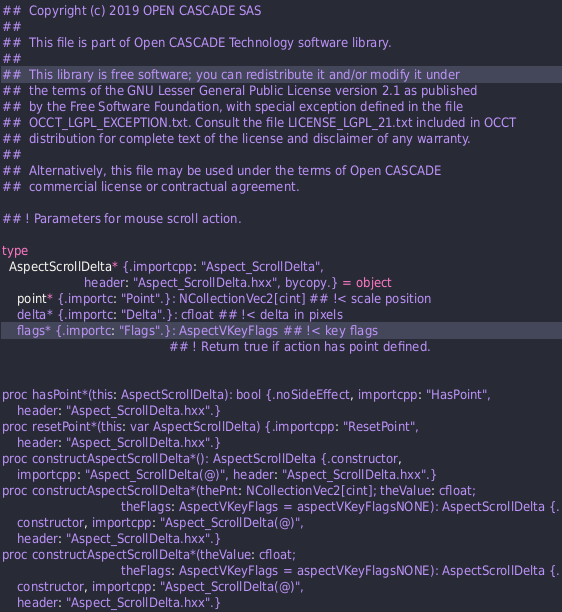<code> <loc_0><loc_0><loc_500><loc_500><_Nim_>##  Copyright (c) 2019 OPEN CASCADE SAS
##
##  This file is part of Open CASCADE Technology software library.
##
##  This library is free software; you can redistribute it and/or modify it under
##  the terms of the GNU Lesser General Public License version 2.1 as published
##  by the Free Software Foundation, with special exception defined in the file
##  OCCT_LGPL_EXCEPTION.txt. Consult the file LICENSE_LGPL_21.txt included in OCCT
##  distribution for complete text of the license and disclaimer of any warranty.
##
##  Alternatively, this file may be used under the terms of Open CASCADE
##  commercial license or contractual agreement.

## ! Parameters for mouse scroll action.

type
  AspectScrollDelta* {.importcpp: "Aspect_ScrollDelta",
                      header: "Aspect_ScrollDelta.hxx", bycopy.} = object
    point* {.importc: "Point".}: NCollectionVec2[cint] ## !< scale position
    delta* {.importc: "Delta".}: cfloat ## !< delta in pixels
    flags* {.importc: "Flags".}: AspectVKeyFlags ## !< key flags
                                             ## ! Return true if action has point defined.


proc hasPoint*(this: AspectScrollDelta): bool {.noSideEffect, importcpp: "HasPoint",
    header: "Aspect_ScrollDelta.hxx".}
proc resetPoint*(this: var AspectScrollDelta) {.importcpp: "ResetPoint",
    header: "Aspect_ScrollDelta.hxx".}
proc constructAspectScrollDelta*(): AspectScrollDelta {.constructor,
    importcpp: "Aspect_ScrollDelta(@)", header: "Aspect_ScrollDelta.hxx".}
proc constructAspectScrollDelta*(thePnt: NCollectionVec2[cint]; theValue: cfloat;
                                theFlags: AspectVKeyFlags = aspectVKeyFlagsNONE): AspectScrollDelta {.
    constructor, importcpp: "Aspect_ScrollDelta(@)",
    header: "Aspect_ScrollDelta.hxx".}
proc constructAspectScrollDelta*(theValue: cfloat;
                                theFlags: AspectVKeyFlags = aspectVKeyFlagsNONE): AspectScrollDelta {.
    constructor, importcpp: "Aspect_ScrollDelta(@)",
    header: "Aspect_ScrollDelta.hxx".}

























</code> 